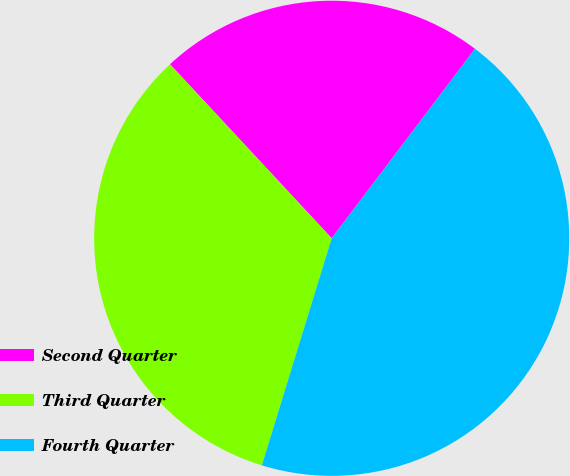Convert chart. <chart><loc_0><loc_0><loc_500><loc_500><pie_chart><fcel>Second Quarter<fcel>Third Quarter<fcel>Fourth Quarter<nl><fcel>22.22%<fcel>33.33%<fcel>44.44%<nl></chart> 